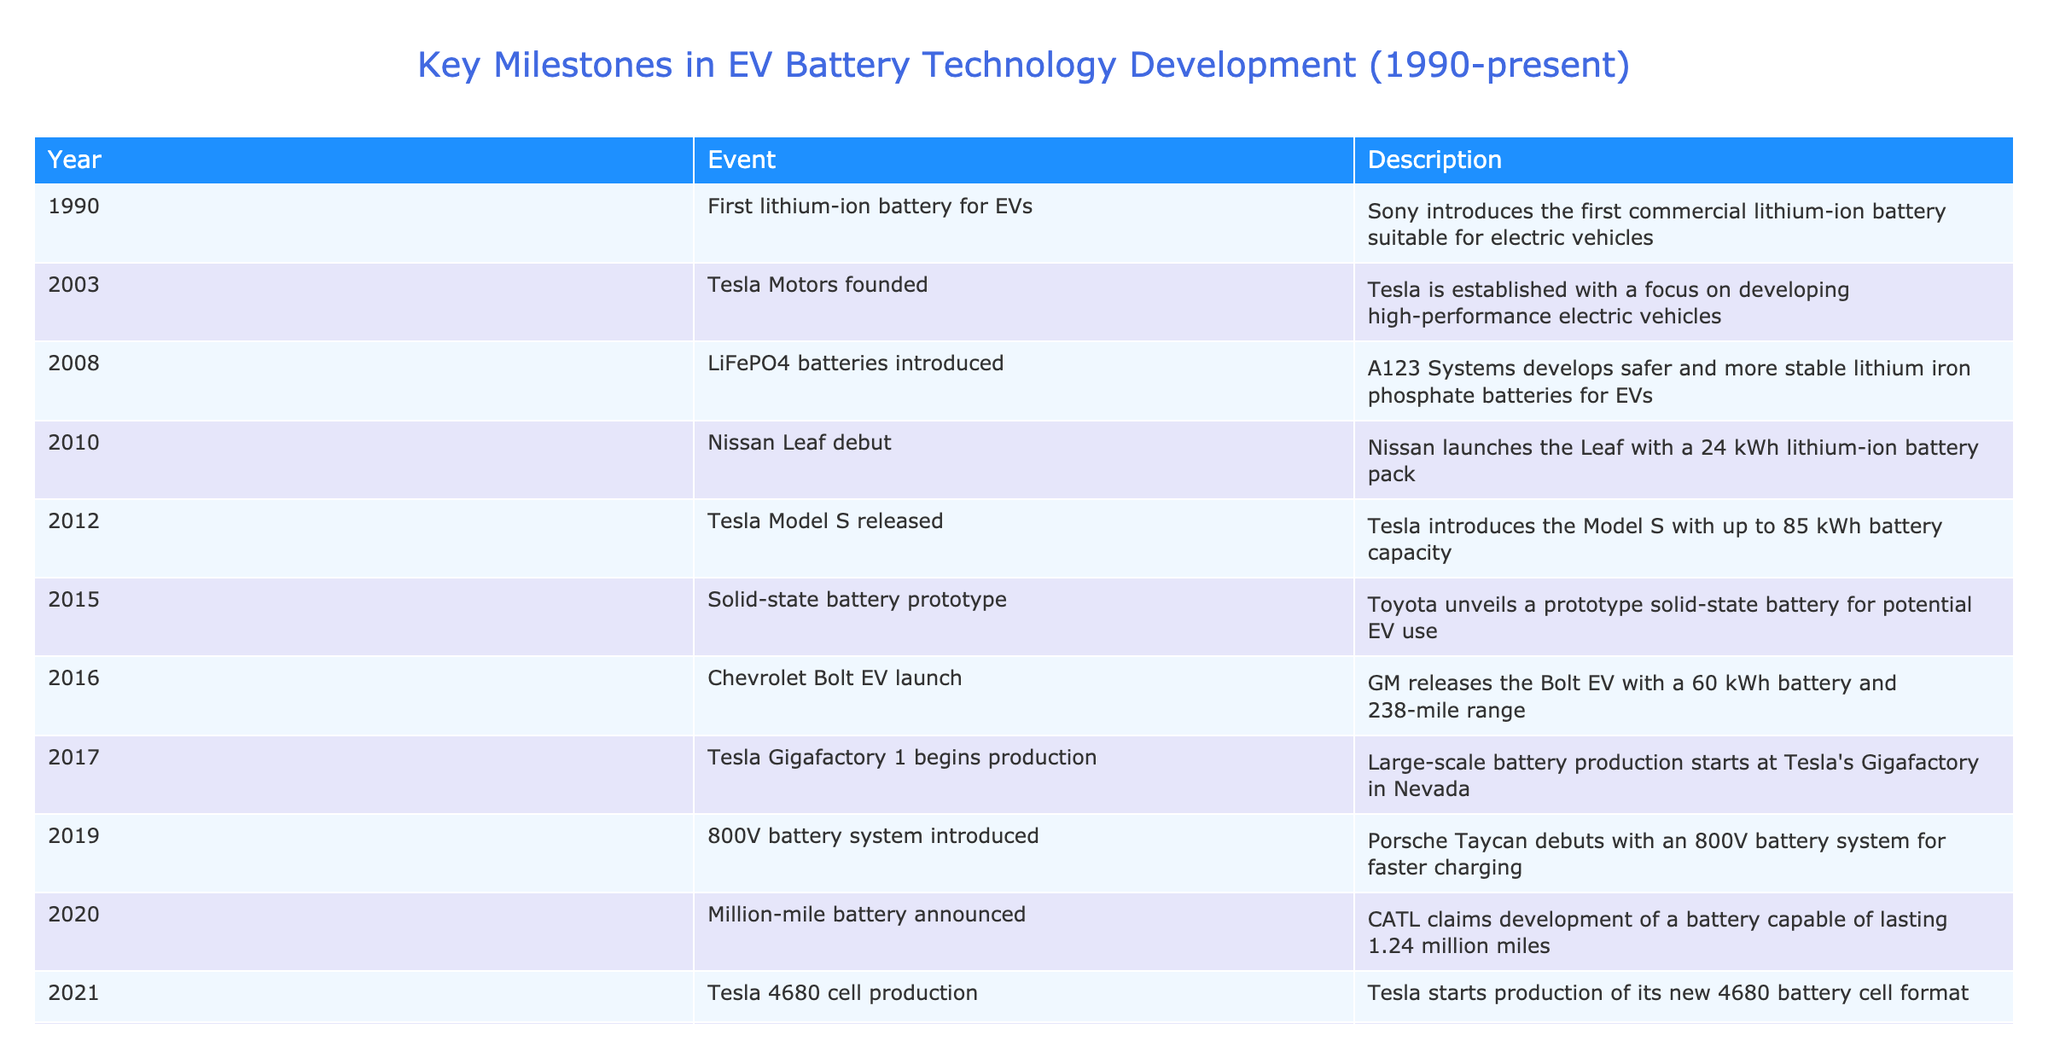What year was the first lithium-ion battery introduced for electric vehicles? The table states that the first lithium-ion battery suitable for electric vehicles was introduced by Sony in the year 1990.
Answer: 1990 Which electric vehicle debut was launched with a 24 kWh lithium-ion battery pack? From the table, the Nissan Leaf debuted in 2010 with a 24 kWh lithium-ion battery pack listed in the description.
Answer: Nissan Leaf How many years were there between the founding of Tesla Motors and the release of the Tesla Model S? Tesla Motors was founded in 2003, and the Tesla Model S was released in 2012. The difference is 2012 - 2003 = 9 years.
Answer: 9 years Did宝马 (BMW) or Samsung introduce any electric vehicle battery technologies according to the table? There are no entries in the table for BMW or Samsung introducing battery technologies for electric vehicles, so the answer is no.
Answer: No What is the development milestone described for 2020? According to the table, in 2020, CATL claimed the development of a battery capable of lasting 1.24 million miles, which is a significant technological advancement in terms of battery longevity.
Answer: Million-mile battery announced How much battery capacity did the Tesla Model S have? The table indicates that the Tesla Model S has a battery capacity of up to 85 kWh as stated in the description for the year 2012.
Answer: 85 kWh Which battery technology milestone occurred first, the introduction of LiFePO4 batteries or the launch of the Chevrolet Bolt EV? The introduction of LiFePO4 batteries took place in 2008, while the Chevrolet Bolt EV was launched in 2016. Since 2008 is earlier than 2016, LiFePO4 batteries were introduced first.
Answer: LiFePO4 batteries introduced What is the difference in years between the introduction of solid-state battery prototypes and the commercial availability of solid-state batteries? The solid-state battery prototype was unveiled in 2015, and the commercial partnership for solid-state batteries was established in 2023. Calculating the difference gives us 2023 - 2015 = 8 years.
Answer: 8 years Which event marks the beginning of large-scale battery production for Tesla? The table notes that large-scale battery production began at Tesla's Gigafactory in Nevada in 2017, marking a significant milestone in production capacity.
Answer: Tesla Gigafactory 1 begins production 